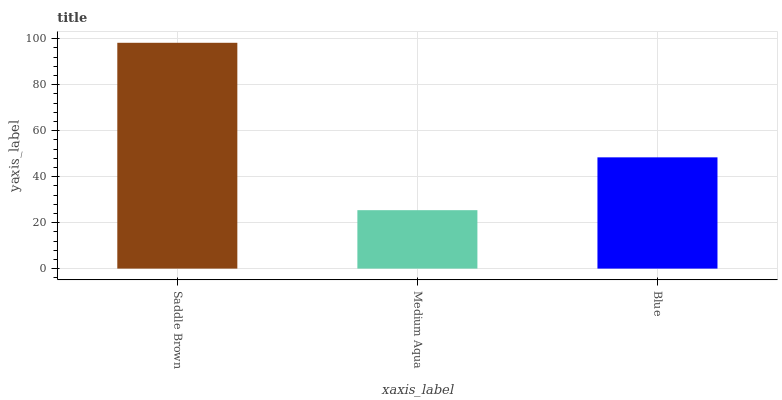Is Medium Aqua the minimum?
Answer yes or no. Yes. Is Saddle Brown the maximum?
Answer yes or no. Yes. Is Blue the minimum?
Answer yes or no. No. Is Blue the maximum?
Answer yes or no. No. Is Blue greater than Medium Aqua?
Answer yes or no. Yes. Is Medium Aqua less than Blue?
Answer yes or no. Yes. Is Medium Aqua greater than Blue?
Answer yes or no. No. Is Blue less than Medium Aqua?
Answer yes or no. No. Is Blue the high median?
Answer yes or no. Yes. Is Blue the low median?
Answer yes or no. Yes. Is Medium Aqua the high median?
Answer yes or no. No. Is Medium Aqua the low median?
Answer yes or no. No. 